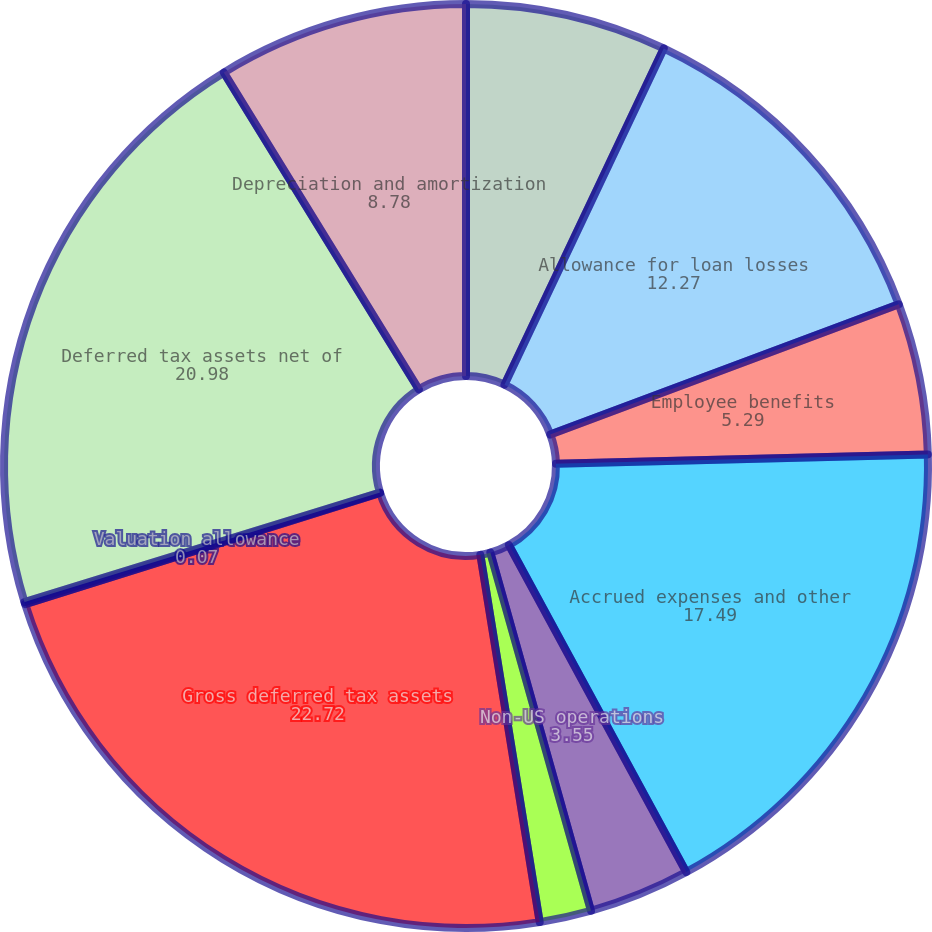<chart> <loc_0><loc_0><loc_500><loc_500><pie_chart><fcel>December 31 (in millions)<fcel>Allowance for loan losses<fcel>Employee benefits<fcel>Accrued expenses and other<fcel>Non-US operations<fcel>Tax attribute carryforwards<fcel>Gross deferred tax assets<fcel>Valuation allowance<fcel>Deferred tax assets net of<fcel>Depreciation and amortization<nl><fcel>7.04%<fcel>12.27%<fcel>5.29%<fcel>17.49%<fcel>3.55%<fcel>1.81%<fcel>22.72%<fcel>0.07%<fcel>20.98%<fcel>8.78%<nl></chart> 